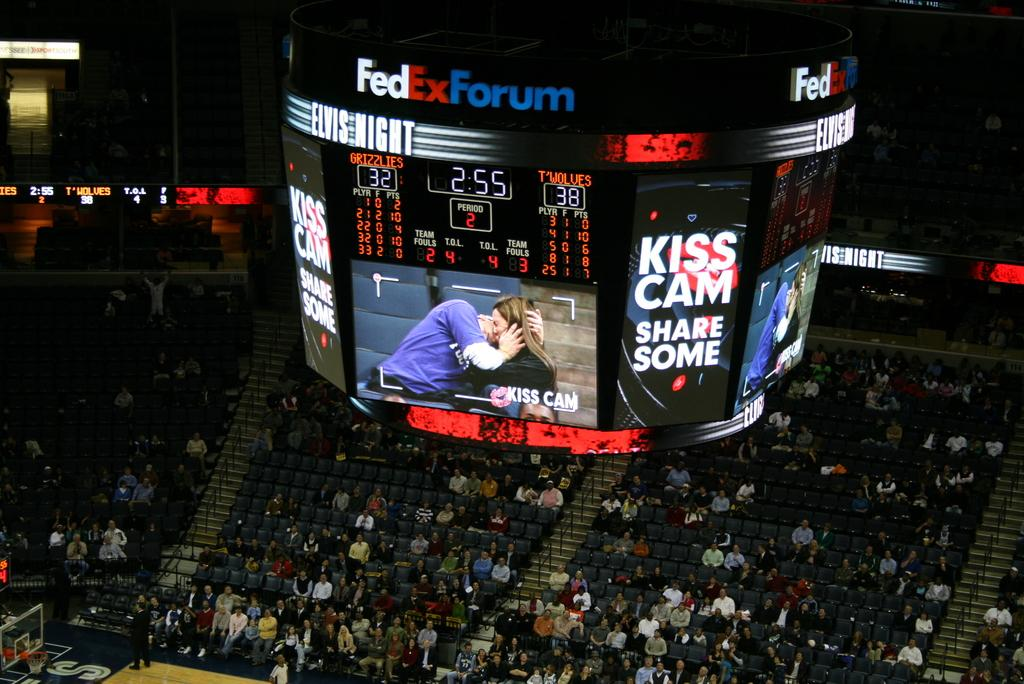Provide a one-sentence caption for the provided image. The Kiss Cam is displaying on a large TV monitor at a stadium. 